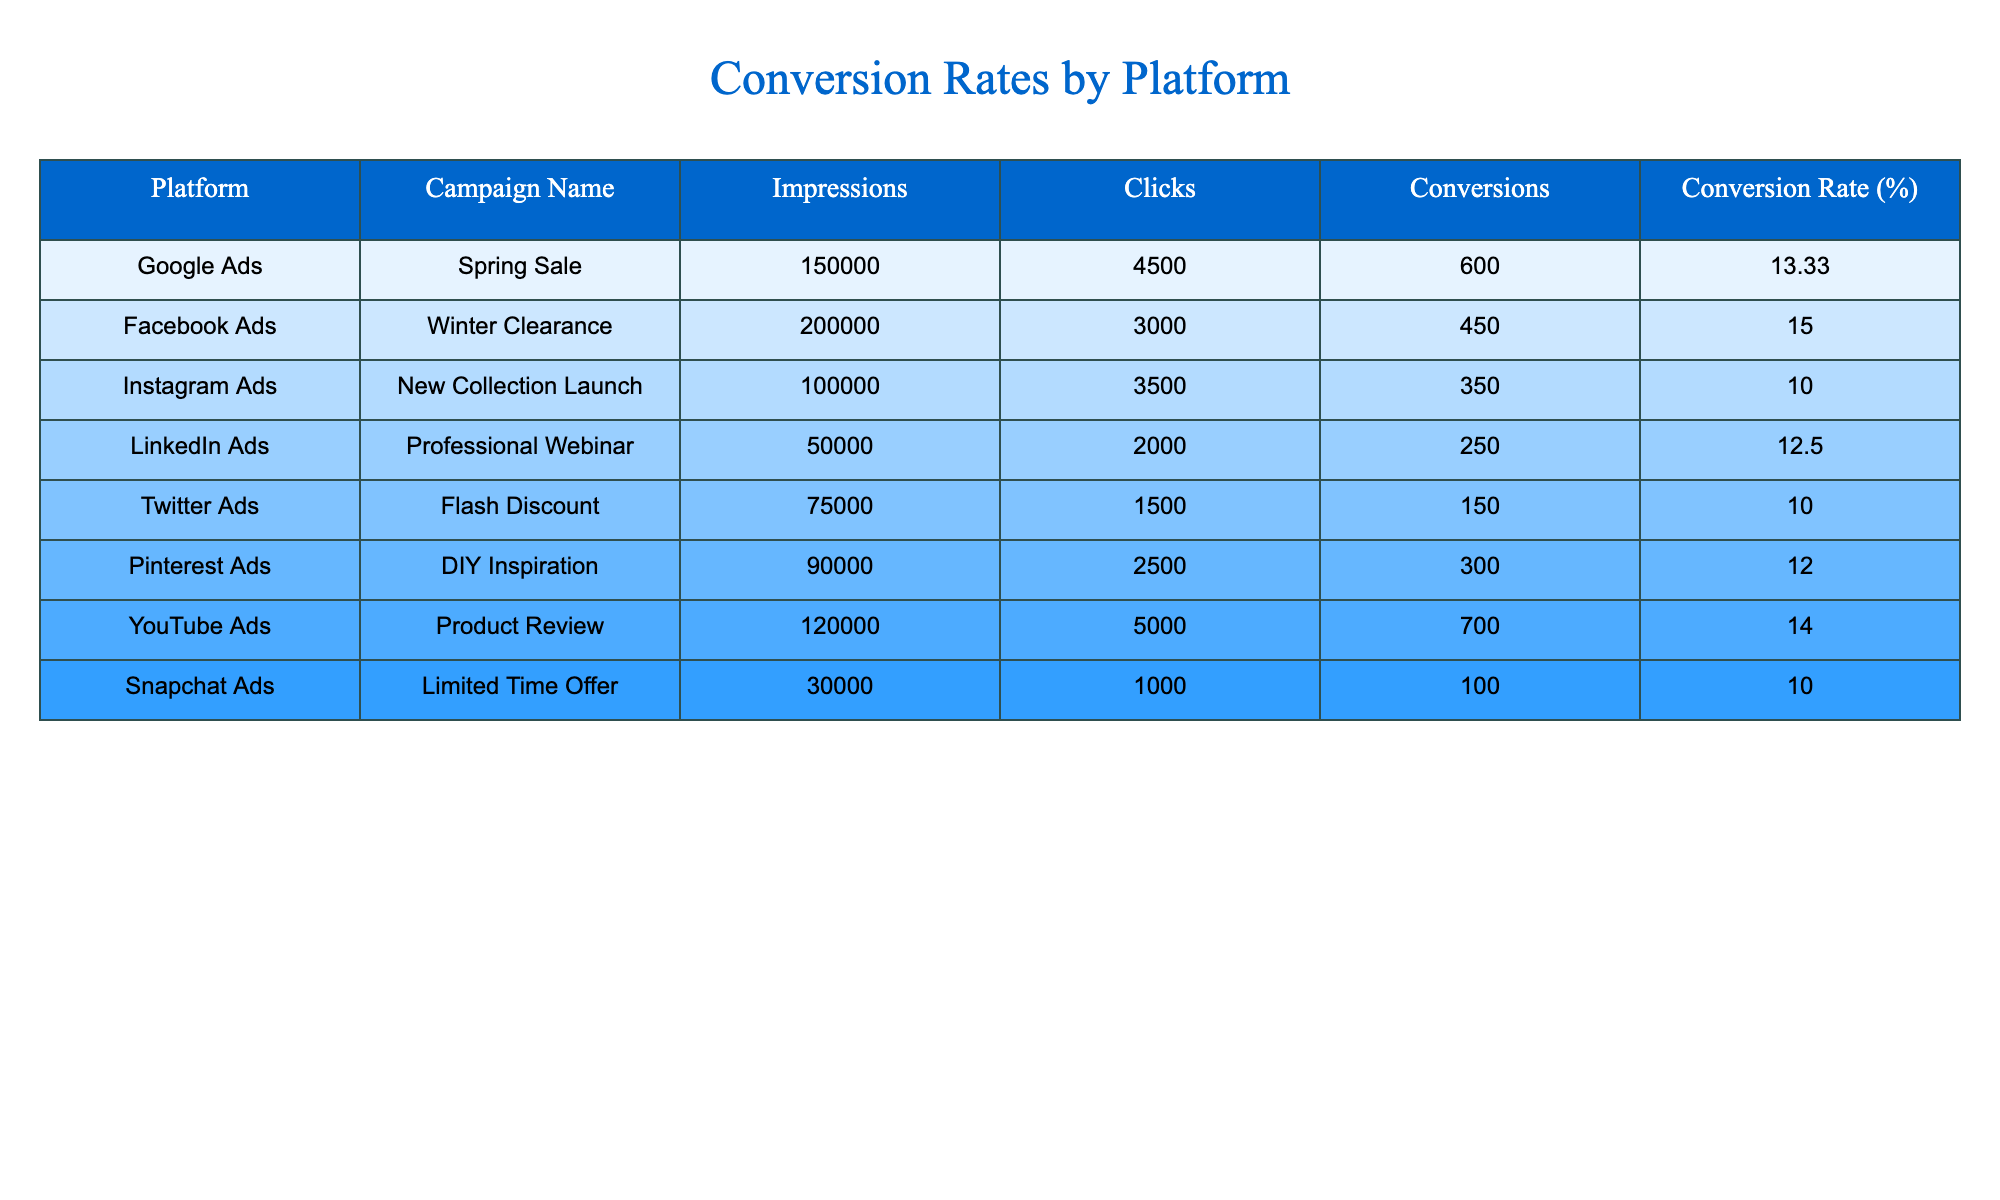What is the conversion rate of Facebook Ads? The table lists the conversion rate of Facebook Ads in the column labeled "Conversion Rate (%)", which shows a value of 15.00 for this platform.
Answer: 15.00 Which platform has the highest conversion rate? By comparing the "Conversion Rate (%)" values from each platform, Facebook Ads has the highest rate at 15.00%.
Answer: Facebook Ads What is the total number of conversions across all platforms? To find the total conversions, we sum the values in the "Conversions" column: 600 + 450 + 350 + 250 + 150 + 300 + 700 + 100 = 2900.
Answer: 2900 Which platform had the most conversions? By reviewing the "Conversions" column, we see that Google Ads has the highest number of conversions, totaling 600.
Answer: Google Ads Is the conversion rate of Instagram Ads greater than the average conversion rate of all platforms? First, we calculate the average conversion rate by adding all rates (13.33 + 15.00 + 10.00 + 12.50 + 10.00 + 12.00 + 14.00 + 10.00) = 92.83. Then, divide by the number of platforms (8): 92.83/8 = 11.60. Since the conversion rate for Instagram Ads is 10.00, which is less than 11.60, the answer is no.
Answer: No What percentage of impressions did the YouTube Ads convert to conversions? The conversion percentage for YouTube Ads can be calculated using the formula (Conversions/Impressions) * 100: (700/120000) * 100 which equals approximately 0.583%.
Answer: 0.583% 